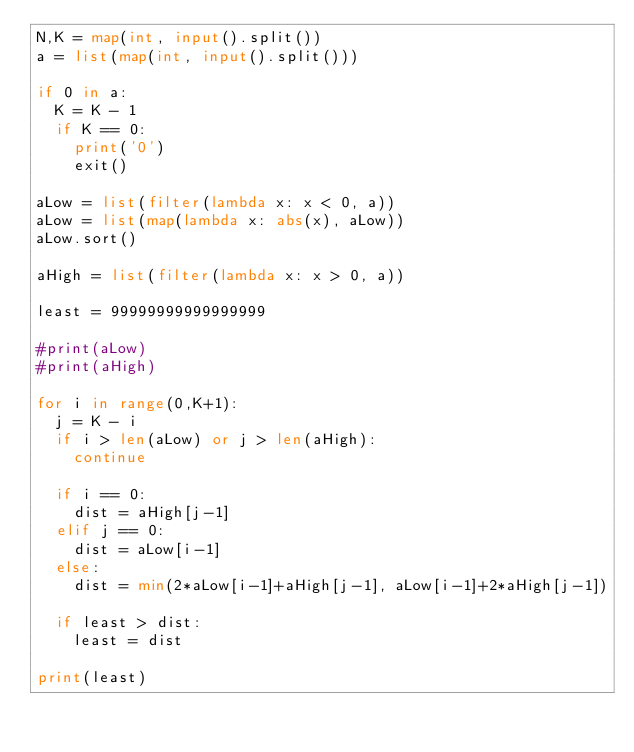Convert code to text. <code><loc_0><loc_0><loc_500><loc_500><_Python_>N,K = map(int, input().split())
a = list(map(int, input().split()))

if 0 in a:
  K = K - 1
  if K == 0:
    print('0')
    exit()

aLow = list(filter(lambda x: x < 0, a))
aLow = list(map(lambda x: abs(x), aLow))
aLow.sort()

aHigh = list(filter(lambda x: x > 0, a))

least = 99999999999999999

#print(aLow)
#print(aHigh)

for i in range(0,K+1):
  j = K - i
  if i > len(aLow) or j > len(aHigh):
    continue

  if i == 0:
    dist = aHigh[j-1]
  elif j == 0:
    dist = aLow[i-1]
  else:
    dist = min(2*aLow[i-1]+aHigh[j-1], aLow[i-1]+2*aHigh[j-1])

  if least > dist:
    least = dist

print(least)
</code> 